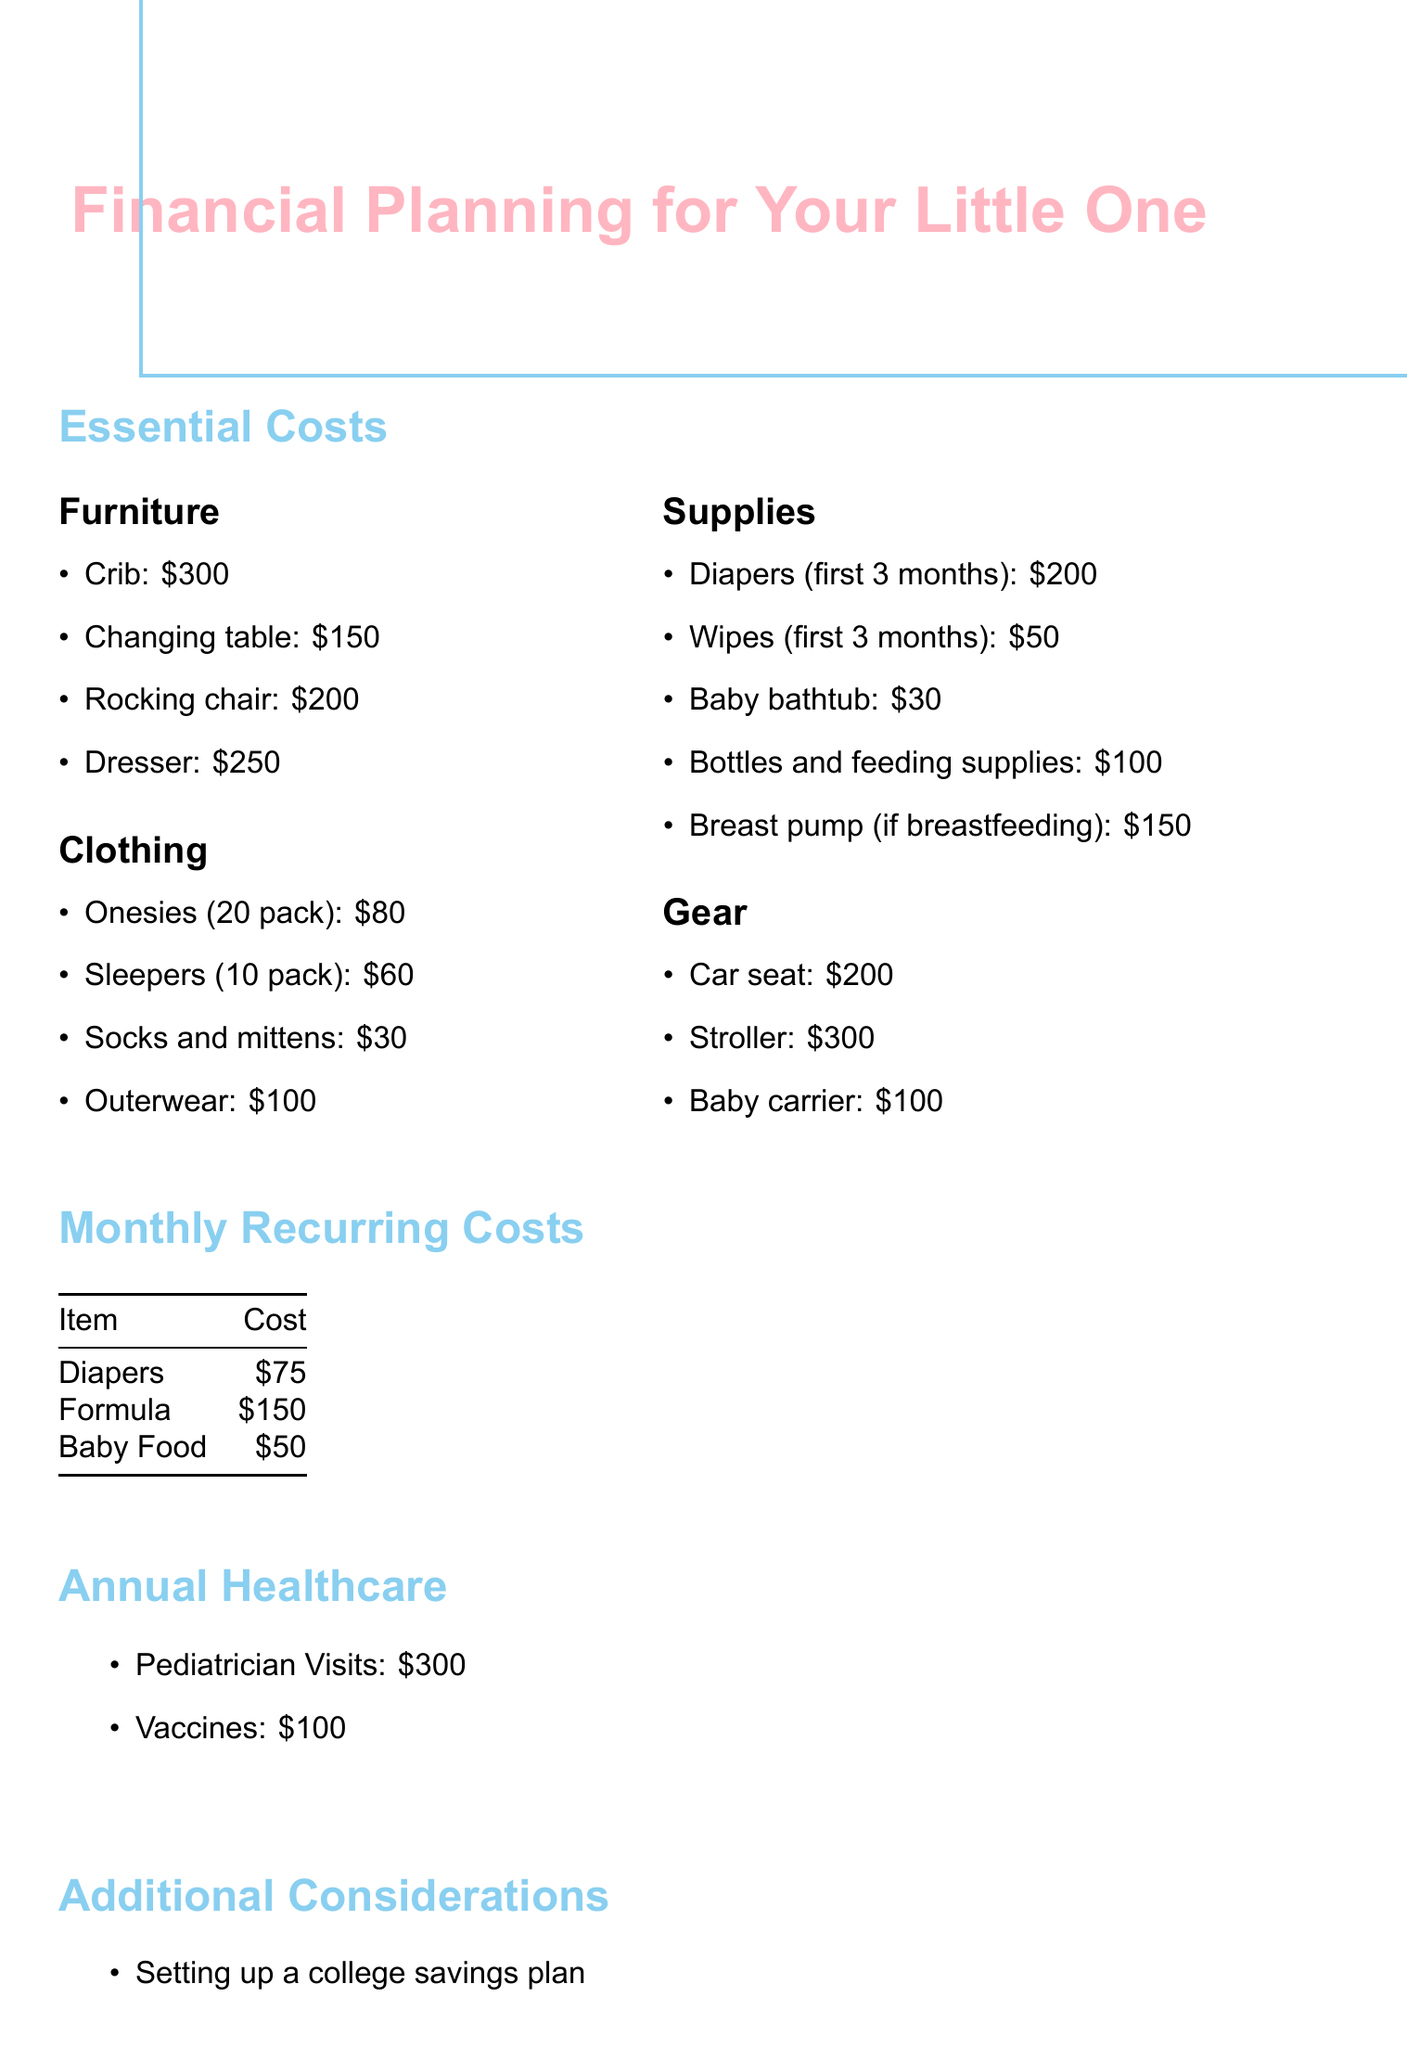What is the cost of a crib? The cost of a crib is listed under the furniture section as $300.
Answer: $300 How much do you need for diapers in the first 3 months? The document specifies that the cost of diapers for the first 3 months is $200.
Answer: $200 What is the total estimated cost for clothing? The total cost for clothing can be calculated by adding the costs of each clothing item: $80 + $60 + $30 + $100 = $270.
Answer: $270 What are the monthly recurring costs for formula? The document lists formula as one of the monthly recurring costs with an amount of $150.
Answer: $150 How much is allocated for annual healthcare visits? The document states that the cost for pediatrician visits annually is $300.
Answer: $300 What items are included in the supplies section? The supplies section includes diapers, wipes, baby bathtub, bottles, and breast pump, making it essential to consider these items.
Answer: Diapers, wipes, baby bathtub, bottles, breast pump What is the total cost for all furniture? The total cost can be calculated by adding the costs of all furniture items: $300 + $150 + $200 + $250 = $900.
Answer: $900 How many items are listed under gear? The gear section lists three items: car seat, stroller, and baby carrier.
Answer: 3 What should parents consider regarding life insurance? The document suggests updating life insurance policies as one of the additional considerations for financial planning.
Answer: Updating life insurance policies 